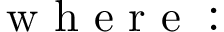<formula> <loc_0><loc_0><loc_500><loc_500>\begin{array} { r l } { w h e r e \colon } \end{array}</formula> 